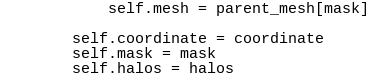Convert code to text. <code><loc_0><loc_0><loc_500><loc_500><_Python_>            self.mesh = parent_mesh[mask]

        self.coordinate = coordinate
        self.mask = mask
        self.halos = halos
</code> 